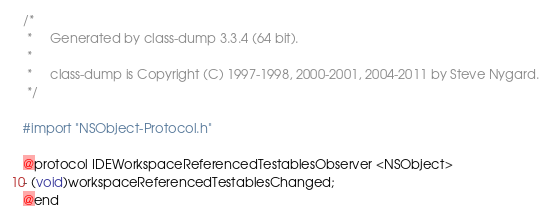<code> <loc_0><loc_0><loc_500><loc_500><_C_>/*
 *     Generated by class-dump 3.3.4 (64 bit).
 *
 *     class-dump is Copyright (C) 1997-1998, 2000-2001, 2004-2011 by Steve Nygard.
 */

#import "NSObject-Protocol.h"

@protocol IDEWorkspaceReferencedTestablesObserver <NSObject>
- (void)workspaceReferencedTestablesChanged;
@end

</code> 